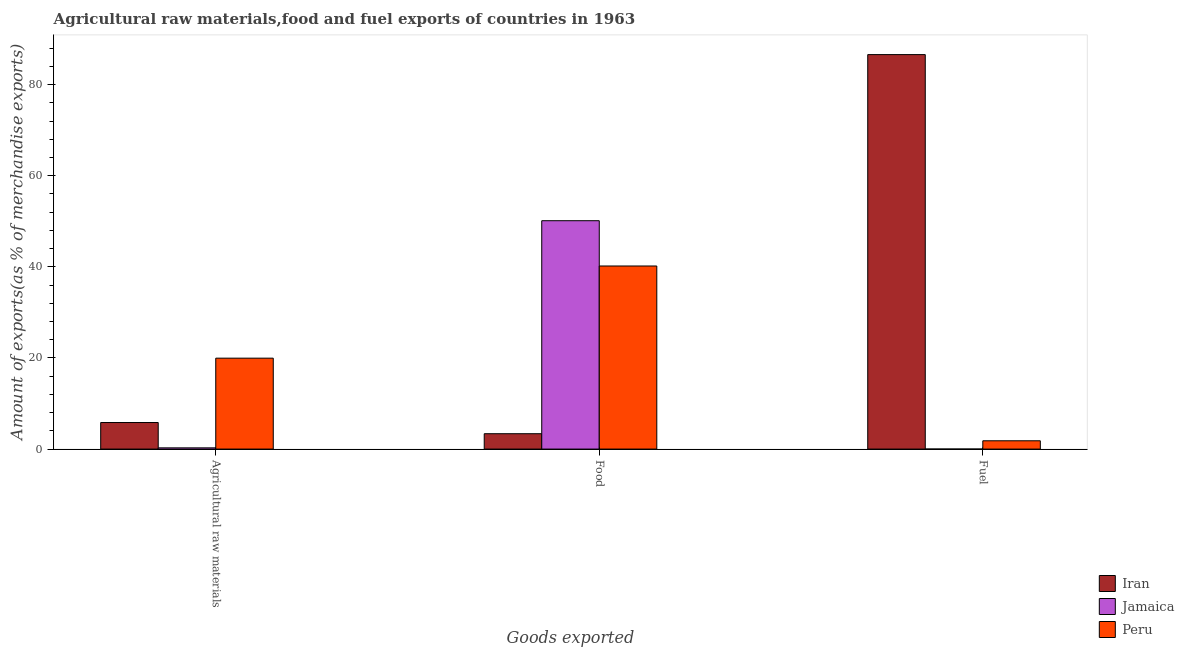Are the number of bars per tick equal to the number of legend labels?
Ensure brevity in your answer.  Yes. Are the number of bars on each tick of the X-axis equal?
Keep it short and to the point. Yes. What is the label of the 1st group of bars from the left?
Provide a succinct answer. Agricultural raw materials. What is the percentage of fuel exports in Peru?
Offer a very short reply. 1.82. Across all countries, what is the maximum percentage of fuel exports?
Your response must be concise. 86.59. Across all countries, what is the minimum percentage of fuel exports?
Make the answer very short. 4.12173240504185e-5. In which country was the percentage of fuel exports maximum?
Your answer should be very brief. Iran. In which country was the percentage of food exports minimum?
Your answer should be compact. Iran. What is the total percentage of raw materials exports in the graph?
Ensure brevity in your answer.  26.05. What is the difference between the percentage of raw materials exports in Jamaica and that in Iran?
Keep it short and to the point. -5.56. What is the difference between the percentage of food exports in Jamaica and the percentage of raw materials exports in Iran?
Give a very brief answer. 44.3. What is the average percentage of food exports per country?
Keep it short and to the point. 31.23. What is the difference between the percentage of fuel exports and percentage of food exports in Jamaica?
Provide a short and direct response. -50.13. What is the ratio of the percentage of raw materials exports in Peru to that in Iran?
Keep it short and to the point. 3.42. Is the percentage of raw materials exports in Peru less than that in Jamaica?
Provide a succinct answer. No. What is the difference between the highest and the second highest percentage of food exports?
Your answer should be compact. 9.94. What is the difference between the highest and the lowest percentage of fuel exports?
Provide a succinct answer. 86.59. What does the 2nd bar from the left in Fuel represents?
Make the answer very short. Jamaica. Is it the case that in every country, the sum of the percentage of raw materials exports and percentage of food exports is greater than the percentage of fuel exports?
Offer a very short reply. No. How many bars are there?
Provide a succinct answer. 9. Are the values on the major ticks of Y-axis written in scientific E-notation?
Provide a short and direct response. No. Does the graph contain grids?
Ensure brevity in your answer.  No. Where does the legend appear in the graph?
Give a very brief answer. Bottom right. How many legend labels are there?
Provide a succinct answer. 3. What is the title of the graph?
Ensure brevity in your answer.  Agricultural raw materials,food and fuel exports of countries in 1963. What is the label or title of the X-axis?
Make the answer very short. Goods exported. What is the label or title of the Y-axis?
Give a very brief answer. Amount of exports(as % of merchandise exports). What is the Amount of exports(as % of merchandise exports) of Iran in Agricultural raw materials?
Your response must be concise. 5.83. What is the Amount of exports(as % of merchandise exports) of Jamaica in Agricultural raw materials?
Your answer should be compact. 0.27. What is the Amount of exports(as % of merchandise exports) in Peru in Agricultural raw materials?
Offer a terse response. 19.96. What is the Amount of exports(as % of merchandise exports) in Iran in Food?
Provide a succinct answer. 3.37. What is the Amount of exports(as % of merchandise exports) of Jamaica in Food?
Provide a succinct answer. 50.13. What is the Amount of exports(as % of merchandise exports) in Peru in Food?
Offer a terse response. 40.19. What is the Amount of exports(as % of merchandise exports) in Iran in Fuel?
Offer a very short reply. 86.59. What is the Amount of exports(as % of merchandise exports) of Jamaica in Fuel?
Keep it short and to the point. 4.12173240504185e-5. What is the Amount of exports(as % of merchandise exports) in Peru in Fuel?
Keep it short and to the point. 1.82. Across all Goods exported, what is the maximum Amount of exports(as % of merchandise exports) in Iran?
Give a very brief answer. 86.59. Across all Goods exported, what is the maximum Amount of exports(as % of merchandise exports) in Jamaica?
Provide a short and direct response. 50.13. Across all Goods exported, what is the maximum Amount of exports(as % of merchandise exports) of Peru?
Make the answer very short. 40.19. Across all Goods exported, what is the minimum Amount of exports(as % of merchandise exports) of Iran?
Provide a succinct answer. 3.37. Across all Goods exported, what is the minimum Amount of exports(as % of merchandise exports) of Jamaica?
Make the answer very short. 4.12173240504185e-5. Across all Goods exported, what is the minimum Amount of exports(as % of merchandise exports) of Peru?
Provide a succinct answer. 1.82. What is the total Amount of exports(as % of merchandise exports) in Iran in the graph?
Keep it short and to the point. 95.79. What is the total Amount of exports(as % of merchandise exports) of Jamaica in the graph?
Your response must be concise. 50.4. What is the total Amount of exports(as % of merchandise exports) in Peru in the graph?
Offer a terse response. 61.96. What is the difference between the Amount of exports(as % of merchandise exports) of Iran in Agricultural raw materials and that in Food?
Offer a very short reply. 2.46. What is the difference between the Amount of exports(as % of merchandise exports) of Jamaica in Agricultural raw materials and that in Food?
Give a very brief answer. -49.86. What is the difference between the Amount of exports(as % of merchandise exports) of Peru in Agricultural raw materials and that in Food?
Your answer should be compact. -20.23. What is the difference between the Amount of exports(as % of merchandise exports) in Iran in Agricultural raw materials and that in Fuel?
Your answer should be very brief. -80.76. What is the difference between the Amount of exports(as % of merchandise exports) in Jamaica in Agricultural raw materials and that in Fuel?
Ensure brevity in your answer.  0.27. What is the difference between the Amount of exports(as % of merchandise exports) in Peru in Agricultural raw materials and that in Fuel?
Offer a very short reply. 18.13. What is the difference between the Amount of exports(as % of merchandise exports) of Iran in Food and that in Fuel?
Keep it short and to the point. -83.22. What is the difference between the Amount of exports(as % of merchandise exports) of Jamaica in Food and that in Fuel?
Give a very brief answer. 50.13. What is the difference between the Amount of exports(as % of merchandise exports) of Peru in Food and that in Fuel?
Keep it short and to the point. 38.37. What is the difference between the Amount of exports(as % of merchandise exports) of Iran in Agricultural raw materials and the Amount of exports(as % of merchandise exports) of Jamaica in Food?
Offer a very short reply. -44.3. What is the difference between the Amount of exports(as % of merchandise exports) in Iran in Agricultural raw materials and the Amount of exports(as % of merchandise exports) in Peru in Food?
Your response must be concise. -34.36. What is the difference between the Amount of exports(as % of merchandise exports) of Jamaica in Agricultural raw materials and the Amount of exports(as % of merchandise exports) of Peru in Food?
Your response must be concise. -39.92. What is the difference between the Amount of exports(as % of merchandise exports) in Iran in Agricultural raw materials and the Amount of exports(as % of merchandise exports) in Jamaica in Fuel?
Keep it short and to the point. 5.83. What is the difference between the Amount of exports(as % of merchandise exports) of Iran in Agricultural raw materials and the Amount of exports(as % of merchandise exports) of Peru in Fuel?
Offer a terse response. 4.01. What is the difference between the Amount of exports(as % of merchandise exports) in Jamaica in Agricultural raw materials and the Amount of exports(as % of merchandise exports) in Peru in Fuel?
Offer a terse response. -1.55. What is the difference between the Amount of exports(as % of merchandise exports) of Iran in Food and the Amount of exports(as % of merchandise exports) of Jamaica in Fuel?
Your response must be concise. 3.37. What is the difference between the Amount of exports(as % of merchandise exports) of Iran in Food and the Amount of exports(as % of merchandise exports) of Peru in Fuel?
Give a very brief answer. 1.55. What is the difference between the Amount of exports(as % of merchandise exports) of Jamaica in Food and the Amount of exports(as % of merchandise exports) of Peru in Fuel?
Ensure brevity in your answer.  48.3. What is the average Amount of exports(as % of merchandise exports) in Iran per Goods exported?
Give a very brief answer. 31.93. What is the average Amount of exports(as % of merchandise exports) of Jamaica per Goods exported?
Offer a very short reply. 16.8. What is the average Amount of exports(as % of merchandise exports) of Peru per Goods exported?
Ensure brevity in your answer.  20.65. What is the difference between the Amount of exports(as % of merchandise exports) in Iran and Amount of exports(as % of merchandise exports) in Jamaica in Agricultural raw materials?
Provide a succinct answer. 5.56. What is the difference between the Amount of exports(as % of merchandise exports) in Iran and Amount of exports(as % of merchandise exports) in Peru in Agricultural raw materials?
Your answer should be compact. -14.13. What is the difference between the Amount of exports(as % of merchandise exports) of Jamaica and Amount of exports(as % of merchandise exports) of Peru in Agricultural raw materials?
Keep it short and to the point. -19.69. What is the difference between the Amount of exports(as % of merchandise exports) in Iran and Amount of exports(as % of merchandise exports) in Jamaica in Food?
Give a very brief answer. -46.75. What is the difference between the Amount of exports(as % of merchandise exports) of Iran and Amount of exports(as % of merchandise exports) of Peru in Food?
Keep it short and to the point. -36.82. What is the difference between the Amount of exports(as % of merchandise exports) in Jamaica and Amount of exports(as % of merchandise exports) in Peru in Food?
Keep it short and to the point. 9.94. What is the difference between the Amount of exports(as % of merchandise exports) of Iran and Amount of exports(as % of merchandise exports) of Jamaica in Fuel?
Ensure brevity in your answer.  86.59. What is the difference between the Amount of exports(as % of merchandise exports) of Iran and Amount of exports(as % of merchandise exports) of Peru in Fuel?
Provide a short and direct response. 84.77. What is the difference between the Amount of exports(as % of merchandise exports) in Jamaica and Amount of exports(as % of merchandise exports) in Peru in Fuel?
Your answer should be very brief. -1.82. What is the ratio of the Amount of exports(as % of merchandise exports) of Iran in Agricultural raw materials to that in Food?
Provide a short and direct response. 1.73. What is the ratio of the Amount of exports(as % of merchandise exports) of Jamaica in Agricultural raw materials to that in Food?
Offer a very short reply. 0.01. What is the ratio of the Amount of exports(as % of merchandise exports) in Peru in Agricultural raw materials to that in Food?
Keep it short and to the point. 0.5. What is the ratio of the Amount of exports(as % of merchandise exports) in Iran in Agricultural raw materials to that in Fuel?
Ensure brevity in your answer.  0.07. What is the ratio of the Amount of exports(as % of merchandise exports) of Jamaica in Agricultural raw materials to that in Fuel?
Provide a short and direct response. 6551.51. What is the ratio of the Amount of exports(as % of merchandise exports) of Peru in Agricultural raw materials to that in Fuel?
Your answer should be compact. 10.96. What is the ratio of the Amount of exports(as % of merchandise exports) in Iran in Food to that in Fuel?
Your response must be concise. 0.04. What is the ratio of the Amount of exports(as % of merchandise exports) in Jamaica in Food to that in Fuel?
Make the answer very short. 1.22e+06. What is the ratio of the Amount of exports(as % of merchandise exports) of Peru in Food to that in Fuel?
Make the answer very short. 22.07. What is the difference between the highest and the second highest Amount of exports(as % of merchandise exports) in Iran?
Offer a terse response. 80.76. What is the difference between the highest and the second highest Amount of exports(as % of merchandise exports) of Jamaica?
Offer a terse response. 49.86. What is the difference between the highest and the second highest Amount of exports(as % of merchandise exports) of Peru?
Provide a succinct answer. 20.23. What is the difference between the highest and the lowest Amount of exports(as % of merchandise exports) of Iran?
Give a very brief answer. 83.22. What is the difference between the highest and the lowest Amount of exports(as % of merchandise exports) in Jamaica?
Ensure brevity in your answer.  50.13. What is the difference between the highest and the lowest Amount of exports(as % of merchandise exports) in Peru?
Provide a succinct answer. 38.37. 